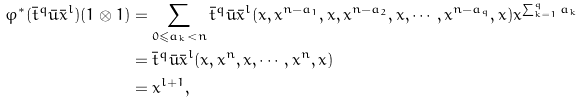<formula> <loc_0><loc_0><loc_500><loc_500>\varphi ^ { * } ( \bar { t } ^ { q } \bar { u } \bar { x } ^ { l } ) ( 1 \otimes 1 ) & = \sum _ { 0 \leqslant a _ { k } < n } \bar { t } ^ { q } \bar { u } \bar { x } ^ { l } ( x , x ^ { n - a _ { 1 } } , x , x ^ { n - a _ { 2 } } , x , \cdots , x ^ { n - a _ { q } } , x ) x ^ { \sum _ { k = 1 } ^ { q } a _ { k } } \\ & = \bar { t } ^ { q } \bar { u } \bar { x } ^ { l } ( x , x ^ { n } , x , \cdots , x ^ { n } , x ) \\ & = x ^ { l + 1 } , \\</formula> 